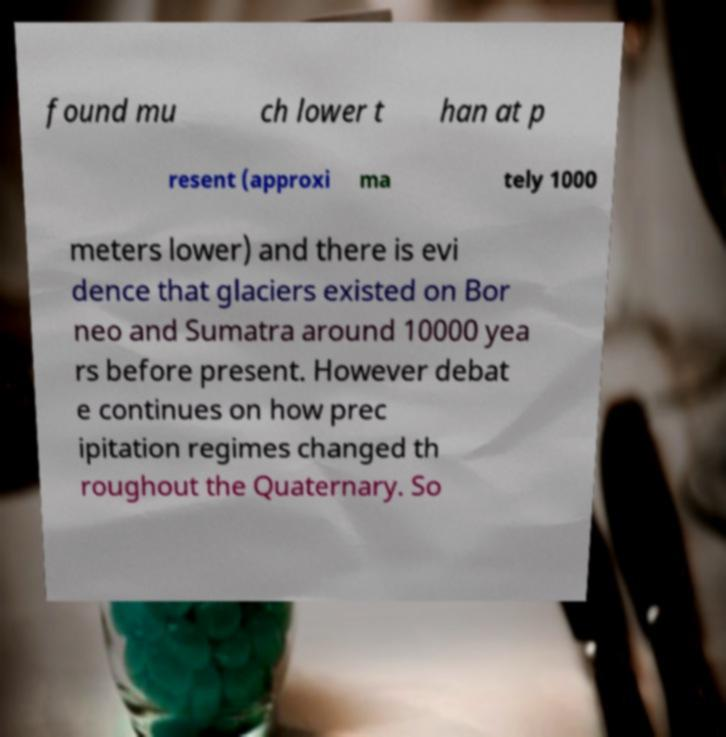What messages or text are displayed in this image? I need them in a readable, typed format. found mu ch lower t han at p resent (approxi ma tely 1000 meters lower) and there is evi dence that glaciers existed on Bor neo and Sumatra around 10000 yea rs before present. However debat e continues on how prec ipitation regimes changed th roughout the Quaternary. So 